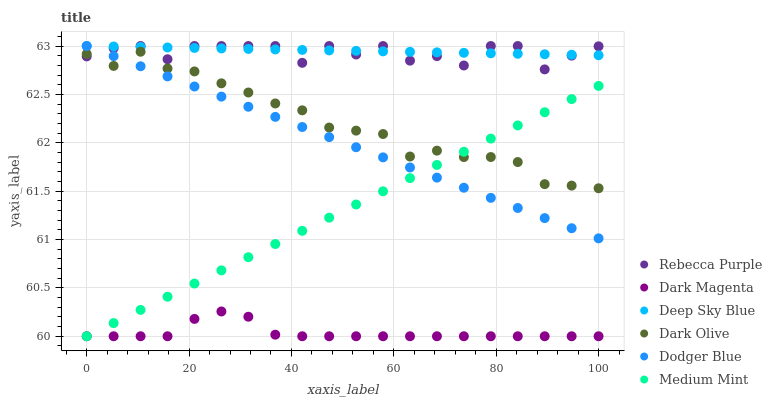Does Dark Magenta have the minimum area under the curve?
Answer yes or no. Yes. Does Deep Sky Blue have the maximum area under the curve?
Answer yes or no. Yes. Does Dark Olive have the minimum area under the curve?
Answer yes or no. No. Does Dark Olive have the maximum area under the curve?
Answer yes or no. No. Is Dodger Blue the smoothest?
Answer yes or no. Yes. Is Rebecca Purple the roughest?
Answer yes or no. Yes. Is Dark Magenta the smoothest?
Answer yes or no. No. Is Dark Magenta the roughest?
Answer yes or no. No. Does Medium Mint have the lowest value?
Answer yes or no. Yes. Does Dark Olive have the lowest value?
Answer yes or no. No. Does Deep Sky Blue have the highest value?
Answer yes or no. Yes. Does Dark Olive have the highest value?
Answer yes or no. No. Is Dark Olive less than Deep Sky Blue?
Answer yes or no. Yes. Is Rebecca Purple greater than Dark Magenta?
Answer yes or no. Yes. Does Dark Olive intersect Dodger Blue?
Answer yes or no. Yes. Is Dark Olive less than Dodger Blue?
Answer yes or no. No. Is Dark Olive greater than Dodger Blue?
Answer yes or no. No. Does Dark Olive intersect Deep Sky Blue?
Answer yes or no. No. 